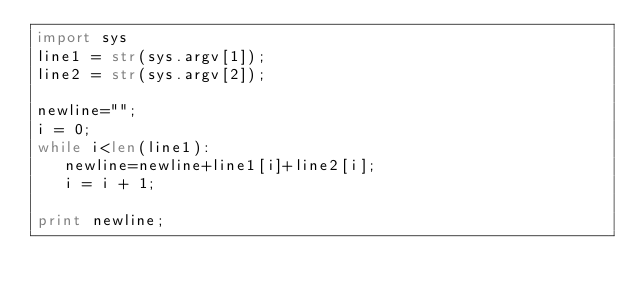<code> <loc_0><loc_0><loc_500><loc_500><_Python_>import sys
line1 = str(sys.argv[1]); 
line2 = str(sys.argv[2]);

newline="";
i = 0;
while i<len(line1):
   newline=newline+line1[i]+line2[i];
   i = i + 1;

print newline;
</code> 